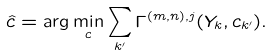<formula> <loc_0><loc_0><loc_500><loc_500>\hat { c } = \arg \min _ { c } \sum _ { k ^ { \prime } } \Gamma ^ { ( m , n ) , j } ( Y _ { k } , c _ { k ^ { \prime } } ) .</formula> 